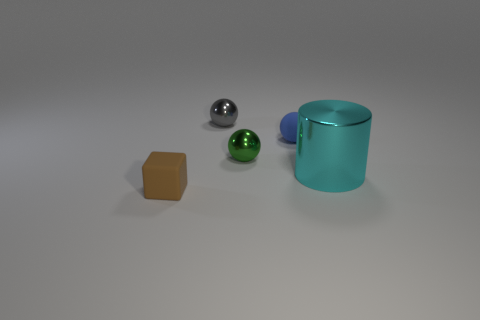What material is the small blue sphere?
Your response must be concise. Rubber. Are there any other things that have the same size as the cyan shiny cylinder?
Your response must be concise. No. How many things are small green metal cylinders or tiny things that are behind the brown thing?
Give a very brief answer. 3. What size is the sphere that is the same material as the small brown cube?
Ensure brevity in your answer.  Small. There is a tiny rubber thing behind the matte object that is in front of the large metallic thing; what is its shape?
Offer a terse response. Sphere. There is a object that is both behind the large thing and on the left side of the green metallic object; what is its size?
Give a very brief answer. Small. Is there a tiny gray object of the same shape as the blue thing?
Offer a terse response. Yes. Is there anything else that is the same shape as the big metal object?
Offer a very short reply. No. The brown thing on the left side of the small matte thing behind the thing that is in front of the big cyan cylinder is made of what material?
Provide a short and direct response. Rubber. Is there a yellow metal thing that has the same size as the blue thing?
Your answer should be very brief. No. 